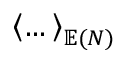<formula> <loc_0><loc_0><loc_500><loc_500>\left \langle \dots \right \rangle _ { \mathbb { E } ( N ) }</formula> 